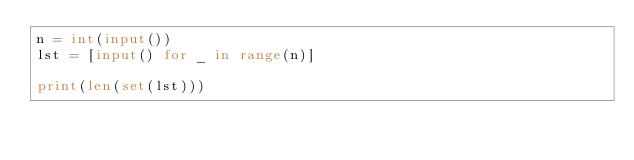Convert code to text. <code><loc_0><loc_0><loc_500><loc_500><_Python_>n = int(input())
lst = [input() for _ in range(n)]

print(len(set(lst)))
</code> 